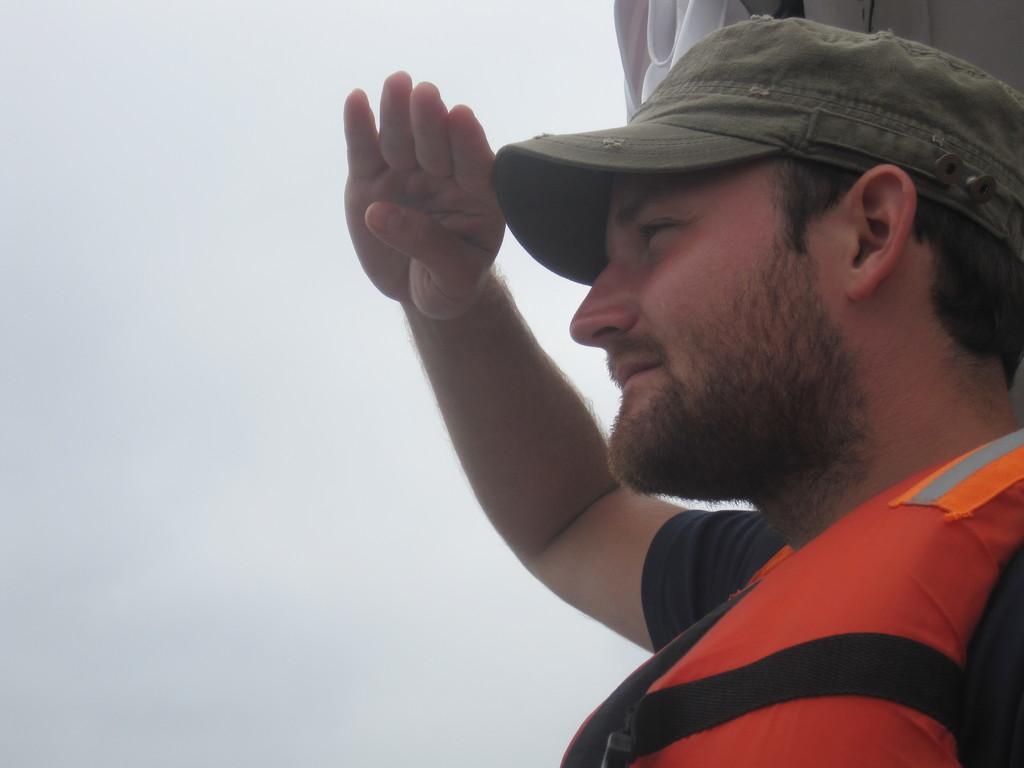Could you give a brief overview of what you see in this image? In the picture I can see a person wearing life jacket and cap is saluting and he is on the right side of the image. In the background, I can see the cloudy sky. 